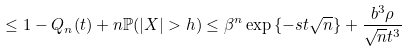<formula> <loc_0><loc_0><loc_500><loc_500>\leq 1 - Q _ { n } ( t ) + n \mathbb { P } ( | X | > h ) \leq \beta ^ { n } \exp { \{ - s t \sqrt { n } \} } + \frac { b ^ { 3 } \rho } { \sqrt { n } t ^ { 3 } }</formula> 